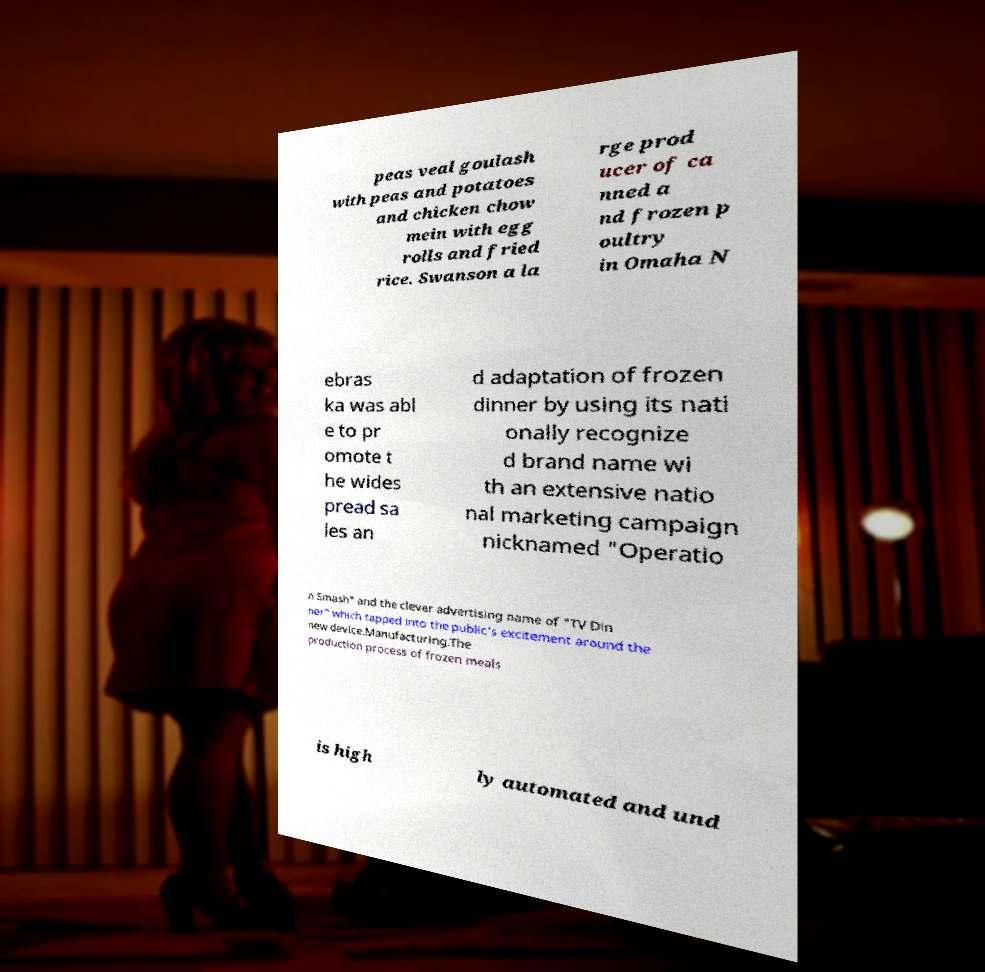Could you extract and type out the text from this image? peas veal goulash with peas and potatoes and chicken chow mein with egg rolls and fried rice. Swanson a la rge prod ucer of ca nned a nd frozen p oultry in Omaha N ebras ka was abl e to pr omote t he wides pread sa les an d adaptation of frozen dinner by using its nati onally recognize d brand name wi th an extensive natio nal marketing campaign nicknamed "Operatio n Smash" and the clever advertising name of "TV Din ner" which tapped into the public's excitement around the new device.Manufacturing.The production process of frozen meals is high ly automated and und 